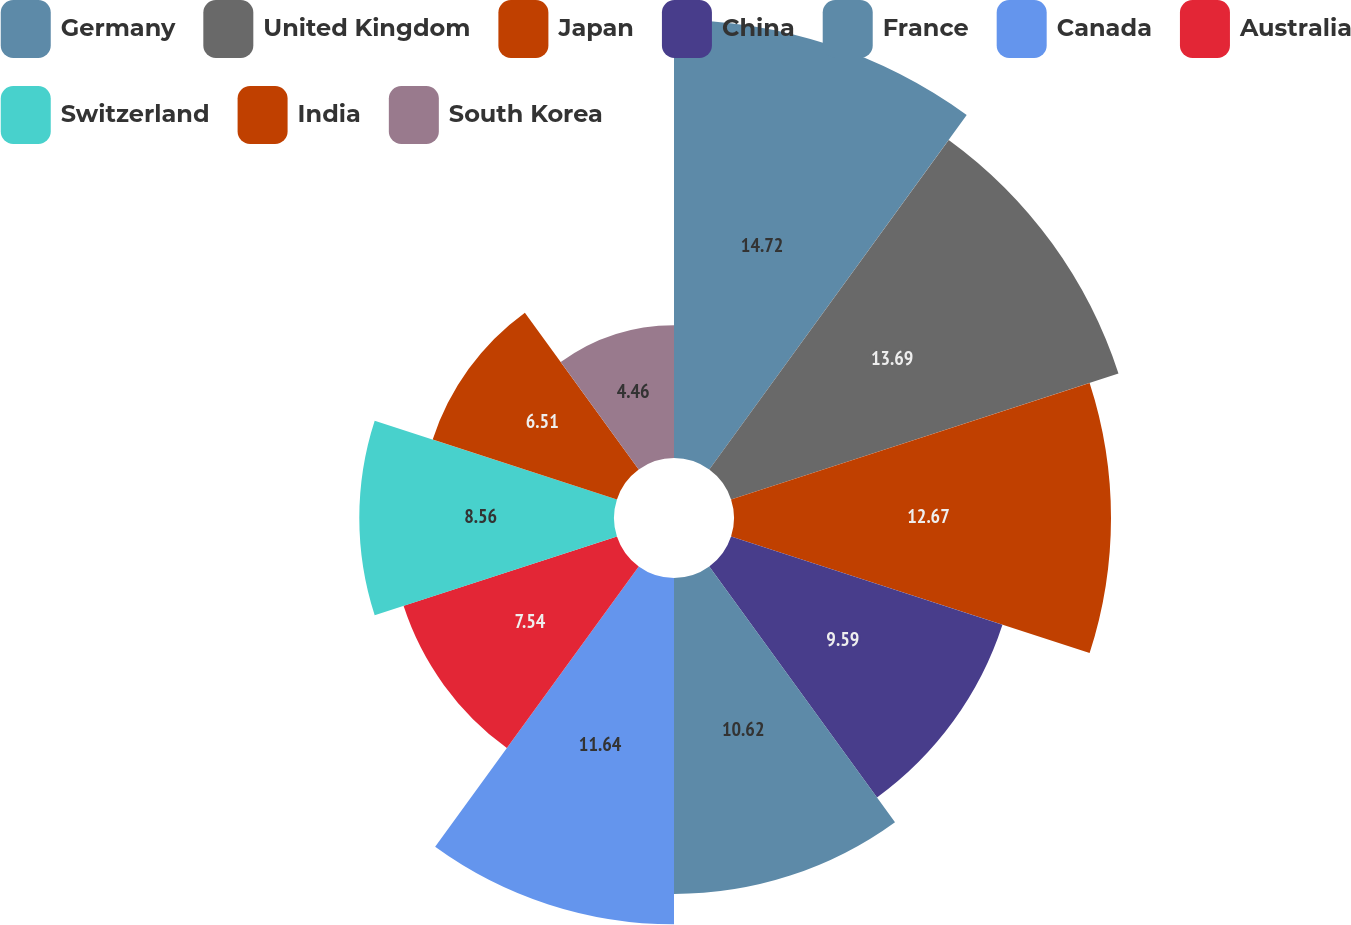<chart> <loc_0><loc_0><loc_500><loc_500><pie_chart><fcel>Germany<fcel>United Kingdom<fcel>Japan<fcel>China<fcel>France<fcel>Canada<fcel>Australia<fcel>Switzerland<fcel>India<fcel>South Korea<nl><fcel>14.72%<fcel>13.69%<fcel>12.67%<fcel>9.59%<fcel>10.62%<fcel>11.64%<fcel>7.54%<fcel>8.56%<fcel>6.51%<fcel>4.46%<nl></chart> 